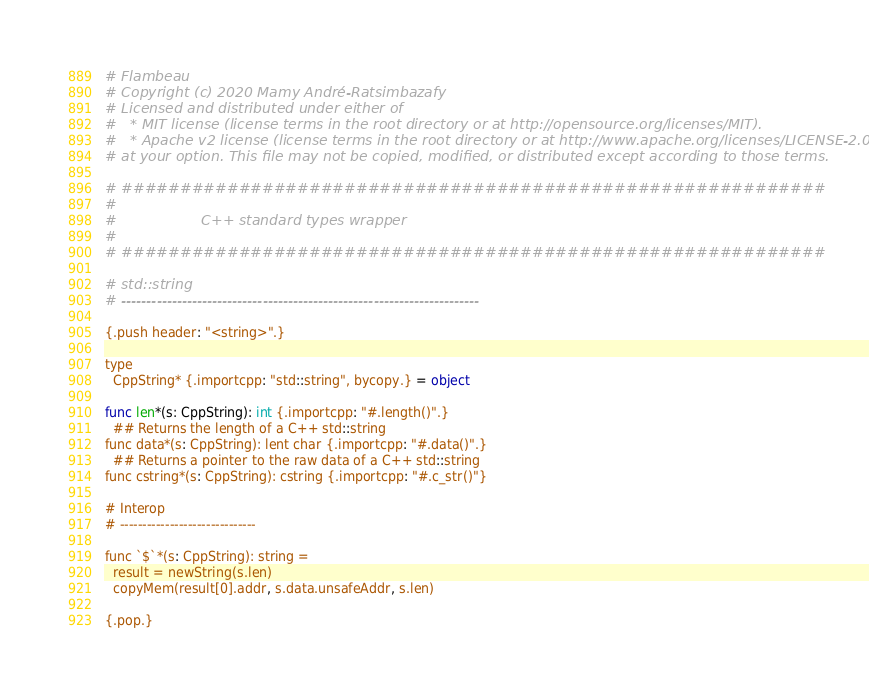Convert code to text. <code><loc_0><loc_0><loc_500><loc_500><_Nim_># Flambeau
# Copyright (c) 2020 Mamy André-Ratsimbazafy
# Licensed and distributed under either of
#   * MIT license (license terms in the root directory or at http://opensource.org/licenses/MIT).
#   * Apache v2 license (license terms in the root directory or at http://www.apache.org/licenses/LICENSE-2.0).
# at your option. This file may not be copied, modified, or distributed except according to those terms.

# ############################################################
#
#                   C++ standard types wrapper
#
# ############################################################

# std::string
# -----------------------------------------------------------------------

{.push header: "<string>".}

type
  CppString* {.importcpp: "std::string", bycopy.} = object

func len*(s: CppString): int {.importcpp: "#.length()".}
  ## Returns the length of a C++ std::string
func data*(s: CppString): lent char {.importcpp: "#.data()".}
  ## Returns a pointer to the raw data of a C++ std::string
func cstring*(s: CppString): cstring {.importcpp: "#.c_str()"}

# Interop
# ------------------------------

func `$`*(s: CppString): string =
  result = newString(s.len)
  copyMem(result[0].addr, s.data.unsafeAddr, s.len)

{.pop.}
</code> 